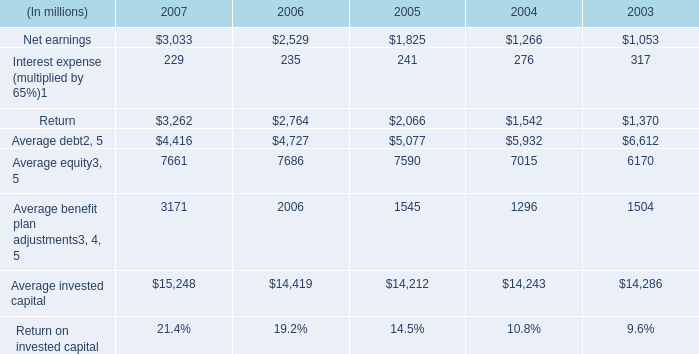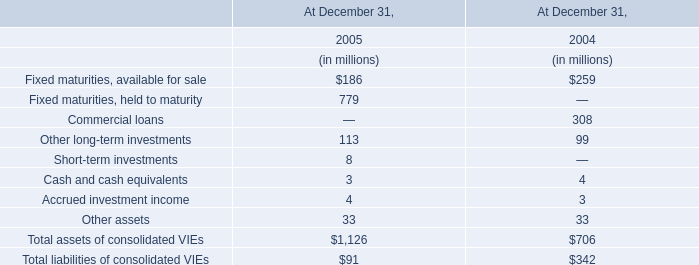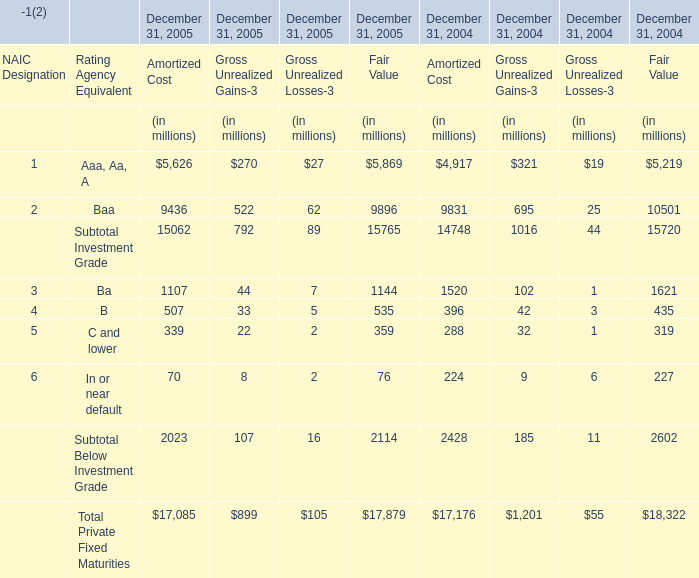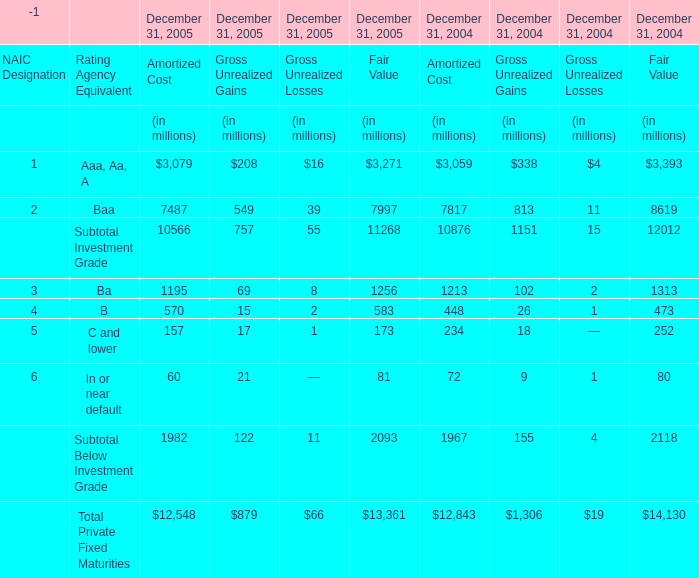Which year is C and lower for Gross Unrealized Gains-3 the least? 
Answer: 2005. 